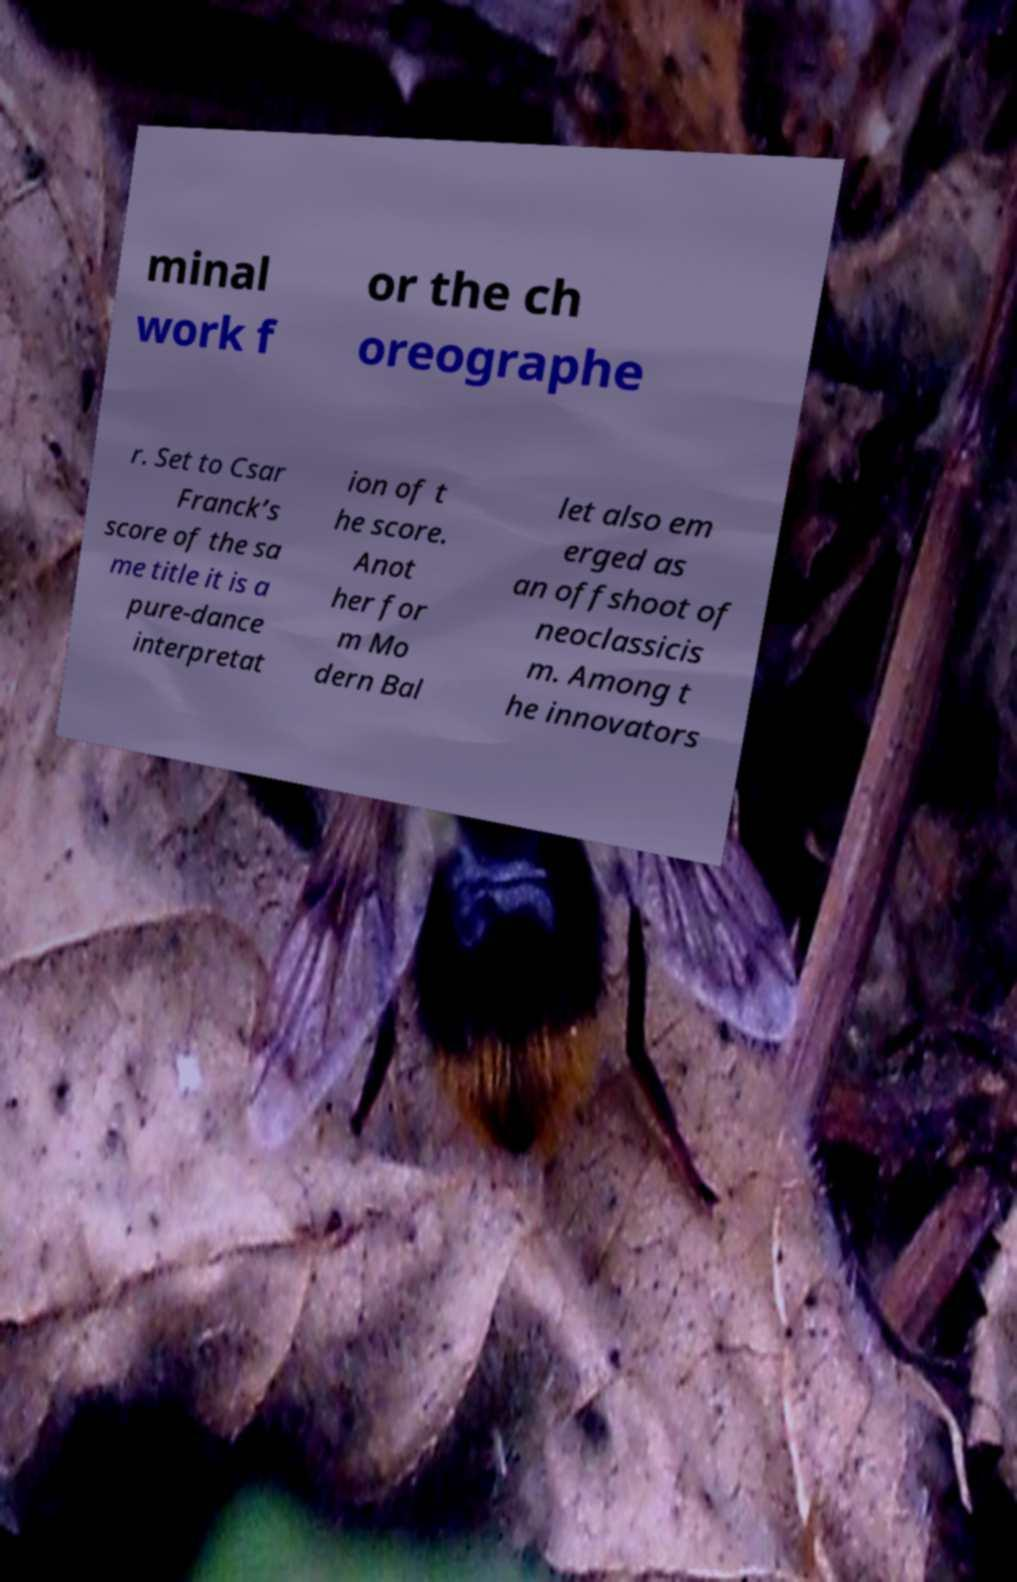There's text embedded in this image that I need extracted. Can you transcribe it verbatim? minal work f or the ch oreographe r. Set to Csar Franck’s score of the sa me title it is a pure-dance interpretat ion of t he score. Anot her for m Mo dern Bal let also em erged as an offshoot of neoclassicis m. Among t he innovators 